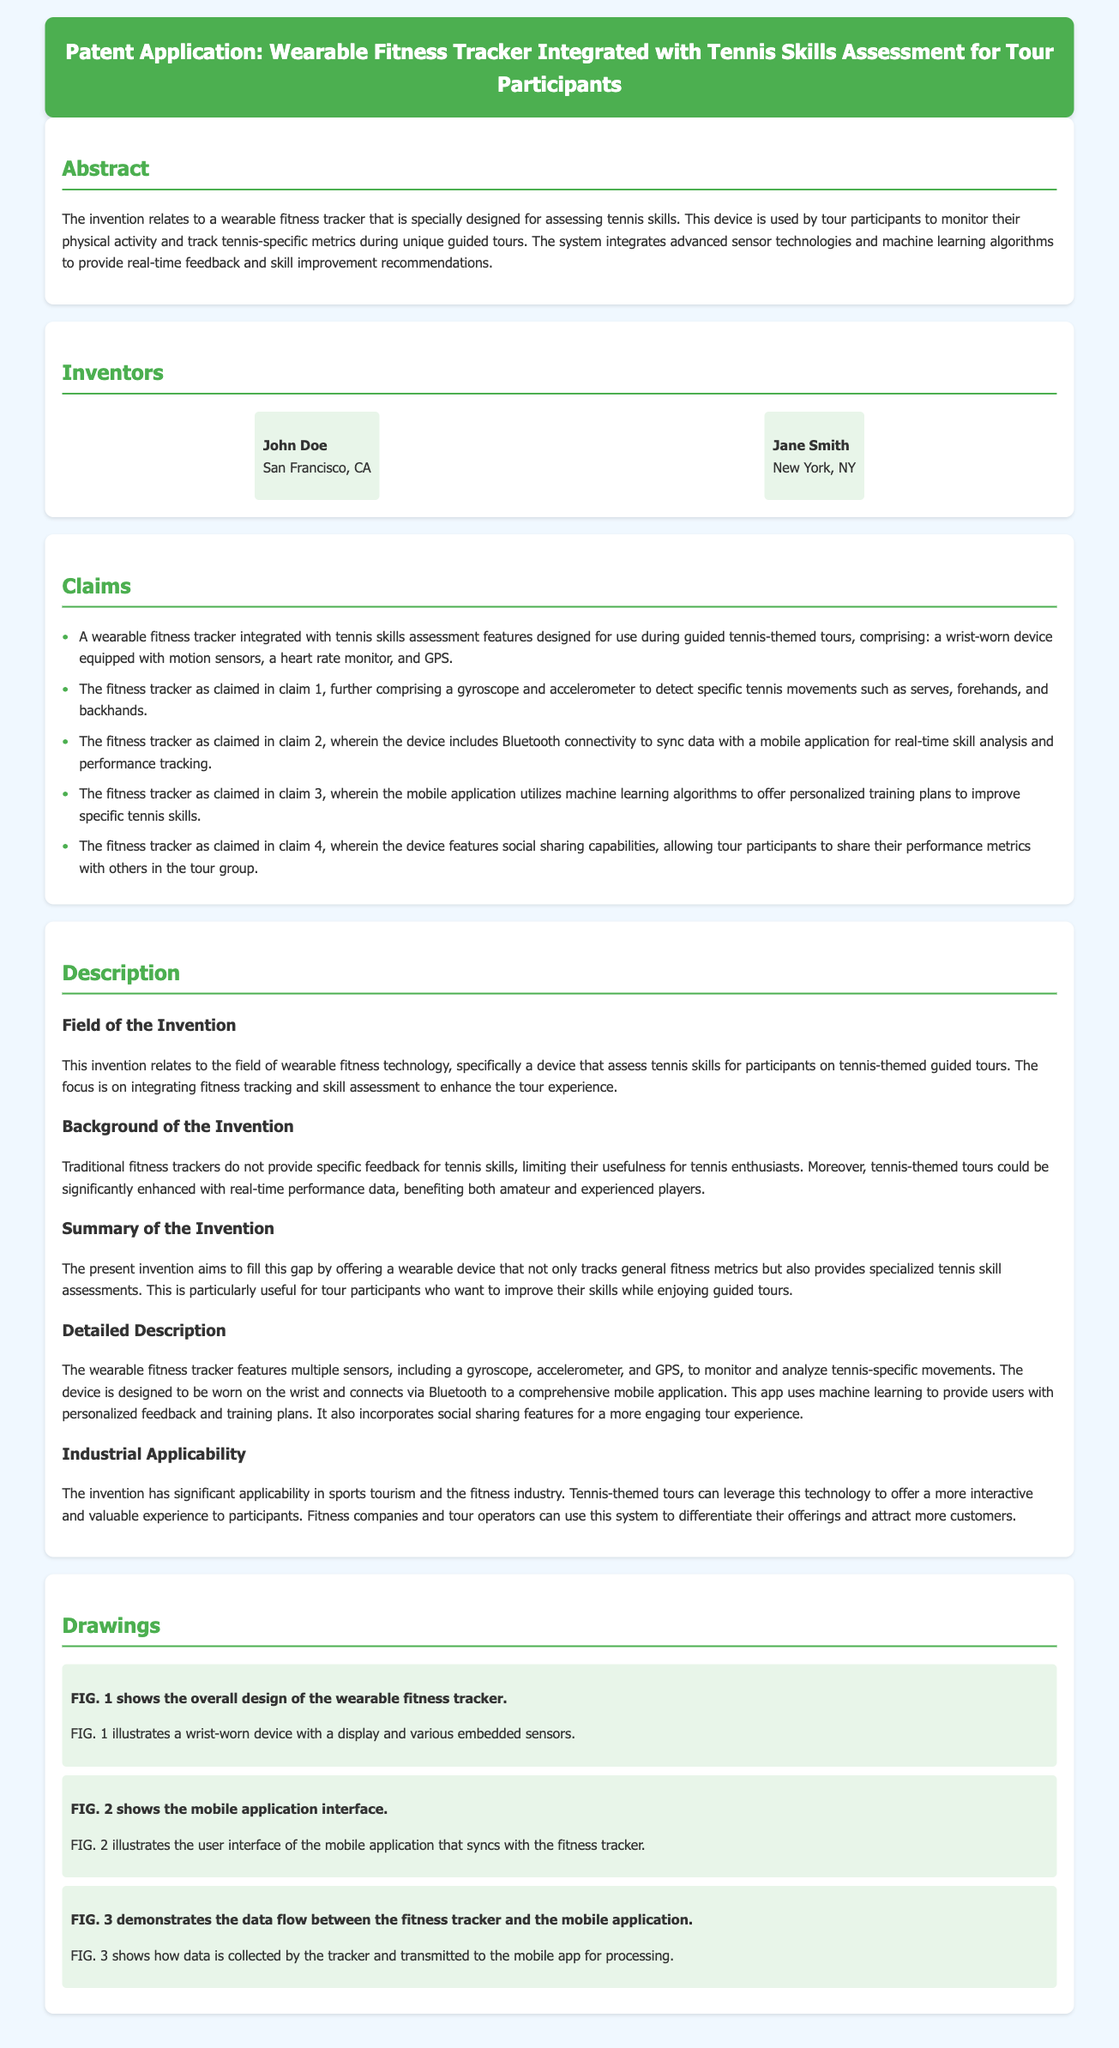What is the title of the patent application? The title of the patent application is provided at the top of the document, which states its main focus and purpose.
Answer: Wearable Fitness Tracker Integrated with Tennis Skills Assessment for Tour Participants Who is one of the inventors? The document lists the names of the inventors in the section titled "Inventors."
Answer: John Doe How many claims are made in the patent application? The number of claims can be counted in the "Claims" section of the document.
Answer: Five What technology does the fitness tracker use to analyze performance? The document describes the use of machine learning algorithms in the mobile application that syncs with the fitness tracker.
Answer: Machine learning What is the primary benefit of the invention mentioned in the summary? The summary emphasizes the device's capability to enhance the tour experience by providing specialized tennis skill assessments.
Answer: Enhance tour experience What is the purpose of the mobile application as per the document? The mobile application is specifically mentioned to offer personalized training plans to improve specific tennis skills.
Answer: Personalized training plans What is the industrial applicability of the invention? The document indicates that the invention applies to sports tourism and the fitness industry, providing distinctive offerings in these fields.
Answer: Sports tourism and fitness industry What does FIG. 1 illustrate? The caption accompanying FIG. 1 in the "Drawings" section describes what is depicted in the figure.
Answer: Overall design of the wearable fitness tracker 